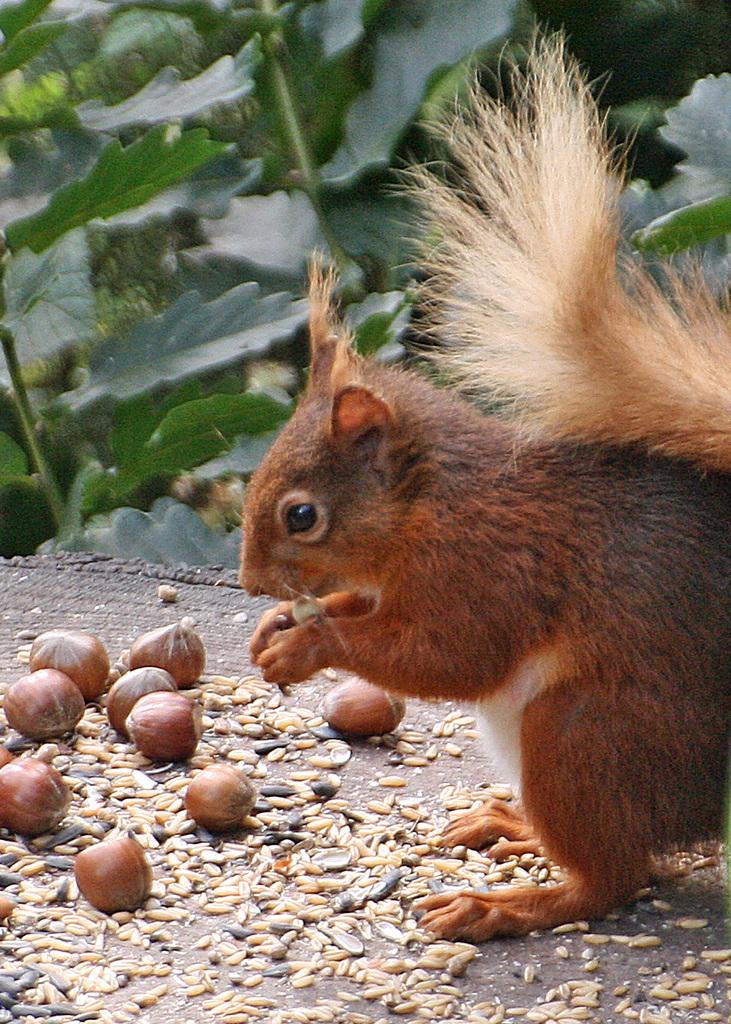What type of animal is in the image? There is a brown squirrel in the image. Where is the squirrel located in the image? The squirrel is standing on the floor. What is the squirrel doing in the image? The squirrel is eating seeds. What else can be seen in the image besides the squirrel? There are plants visible in the image. What is the name of the squirrel's brother in the image? There is no mention of a brother or any other squirrels in the image. 